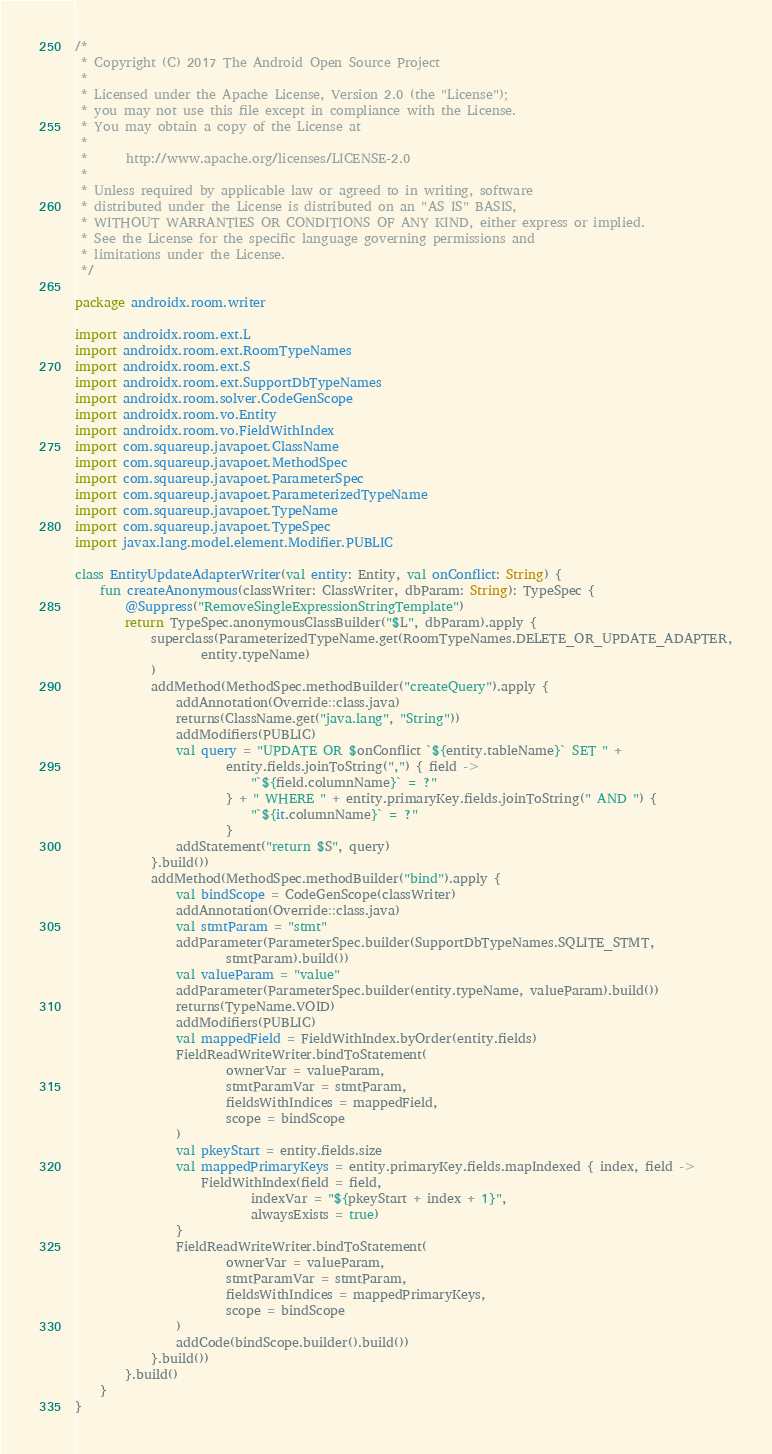Convert code to text. <code><loc_0><loc_0><loc_500><loc_500><_Kotlin_>/*
 * Copyright (C) 2017 The Android Open Source Project
 *
 * Licensed under the Apache License, Version 2.0 (the "License");
 * you may not use this file except in compliance with the License.
 * You may obtain a copy of the License at
 *
 *      http://www.apache.org/licenses/LICENSE-2.0
 *
 * Unless required by applicable law or agreed to in writing, software
 * distributed under the License is distributed on an "AS IS" BASIS,
 * WITHOUT WARRANTIES OR CONDITIONS OF ANY KIND, either express or implied.
 * See the License for the specific language governing permissions and
 * limitations under the License.
 */

package androidx.room.writer

import androidx.room.ext.L
import androidx.room.ext.RoomTypeNames
import androidx.room.ext.S
import androidx.room.ext.SupportDbTypeNames
import androidx.room.solver.CodeGenScope
import androidx.room.vo.Entity
import androidx.room.vo.FieldWithIndex
import com.squareup.javapoet.ClassName
import com.squareup.javapoet.MethodSpec
import com.squareup.javapoet.ParameterSpec
import com.squareup.javapoet.ParameterizedTypeName
import com.squareup.javapoet.TypeName
import com.squareup.javapoet.TypeSpec
import javax.lang.model.element.Modifier.PUBLIC

class EntityUpdateAdapterWriter(val entity: Entity, val onConflict: String) {
    fun createAnonymous(classWriter: ClassWriter, dbParam: String): TypeSpec {
        @Suppress("RemoveSingleExpressionStringTemplate")
        return TypeSpec.anonymousClassBuilder("$L", dbParam).apply {
            superclass(ParameterizedTypeName.get(RoomTypeNames.DELETE_OR_UPDATE_ADAPTER,
                    entity.typeName)
            )
            addMethod(MethodSpec.methodBuilder("createQuery").apply {
                addAnnotation(Override::class.java)
                returns(ClassName.get("java.lang", "String"))
                addModifiers(PUBLIC)
                val query = "UPDATE OR $onConflict `${entity.tableName}` SET " +
                        entity.fields.joinToString(",") { field ->
                            "`${field.columnName}` = ?"
                        } + " WHERE " + entity.primaryKey.fields.joinToString(" AND ") {
                            "`${it.columnName}` = ?"
                        }
                addStatement("return $S", query)
            }.build())
            addMethod(MethodSpec.methodBuilder("bind").apply {
                val bindScope = CodeGenScope(classWriter)
                addAnnotation(Override::class.java)
                val stmtParam = "stmt"
                addParameter(ParameterSpec.builder(SupportDbTypeNames.SQLITE_STMT,
                        stmtParam).build())
                val valueParam = "value"
                addParameter(ParameterSpec.builder(entity.typeName, valueParam).build())
                returns(TypeName.VOID)
                addModifiers(PUBLIC)
                val mappedField = FieldWithIndex.byOrder(entity.fields)
                FieldReadWriteWriter.bindToStatement(
                        ownerVar = valueParam,
                        stmtParamVar = stmtParam,
                        fieldsWithIndices = mappedField,
                        scope = bindScope
                )
                val pkeyStart = entity.fields.size
                val mappedPrimaryKeys = entity.primaryKey.fields.mapIndexed { index, field ->
                    FieldWithIndex(field = field,
                            indexVar = "${pkeyStart + index + 1}",
                            alwaysExists = true)
                }
                FieldReadWriteWriter.bindToStatement(
                        ownerVar = valueParam,
                        stmtParamVar = stmtParam,
                        fieldsWithIndices = mappedPrimaryKeys,
                        scope = bindScope
                )
                addCode(bindScope.builder().build())
            }.build())
        }.build()
    }
}
</code> 